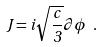Convert formula to latex. <formula><loc_0><loc_0><loc_500><loc_500>J = i \sqrt { \frac { c } { 3 } } \partial \phi \ .</formula> 